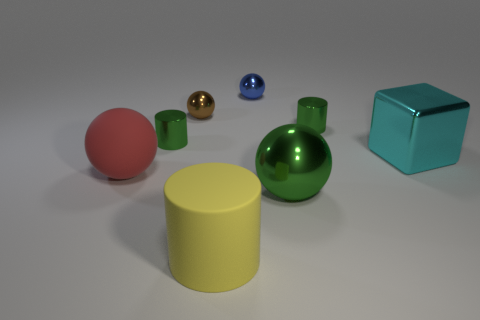Are there any green objects that have the same shape as the large red matte thing?
Provide a succinct answer. Yes. What number of objects are small things that are to the right of the red rubber sphere or blue metallic balls?
Ensure brevity in your answer.  4. Is the number of large green matte blocks greater than the number of matte spheres?
Ensure brevity in your answer.  No. Is there a green thing that has the same size as the red rubber thing?
Ensure brevity in your answer.  Yes. What number of things are either green metallic cylinders that are on the right side of the green metal ball or green objects that are behind the large block?
Your answer should be very brief. 2. What color is the cylinder that is behind the small green cylinder to the left of the tiny blue object?
Offer a very short reply. Green. What color is the large block that is made of the same material as the blue thing?
Provide a short and direct response. Cyan. What number of big matte objects have the same color as the large block?
Your answer should be very brief. 0. How many objects are either small cyan shiny things or large red rubber things?
Your answer should be compact. 1. The brown metallic thing that is the same size as the blue metallic ball is what shape?
Offer a very short reply. Sphere. 